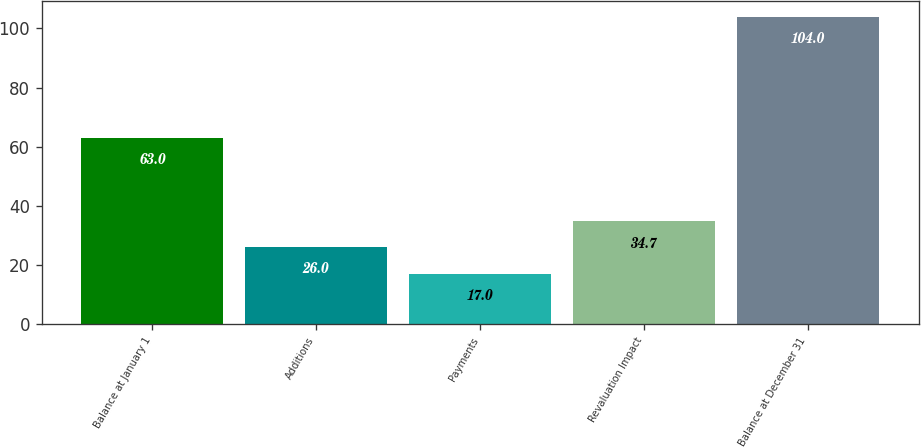Convert chart to OTSL. <chart><loc_0><loc_0><loc_500><loc_500><bar_chart><fcel>Balance at January 1<fcel>Additions<fcel>Payments<fcel>Revaluation Impact<fcel>Balance at December 31<nl><fcel>63<fcel>26<fcel>17<fcel>34.7<fcel>104<nl></chart> 